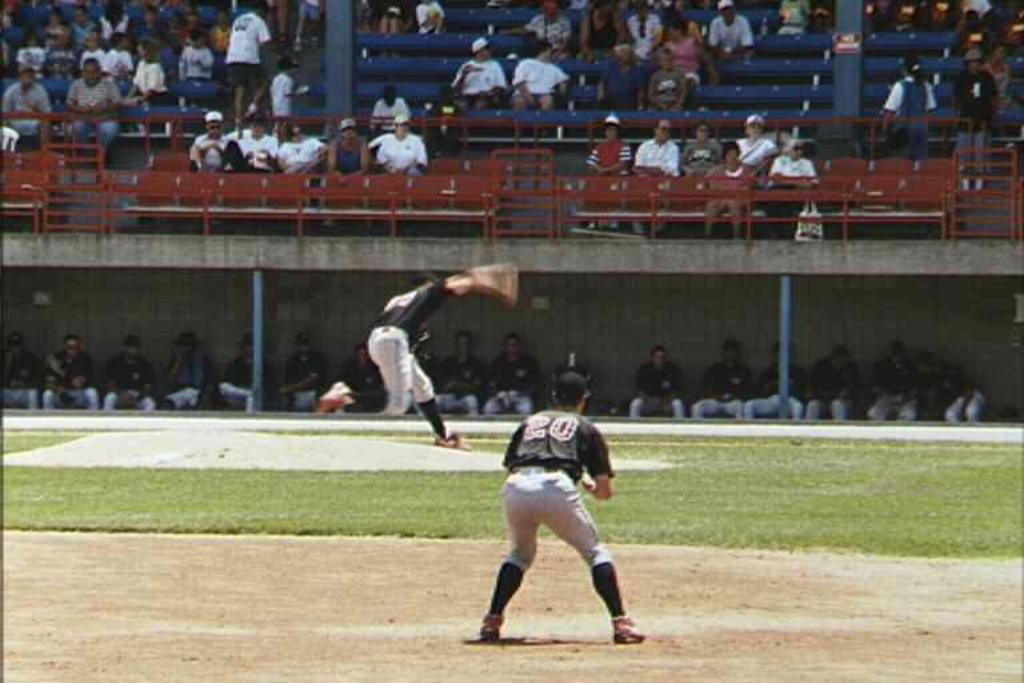<image>
Create a compact narrative representing the image presented. A man is on the baseball field and his shirt has "20" on the back. 